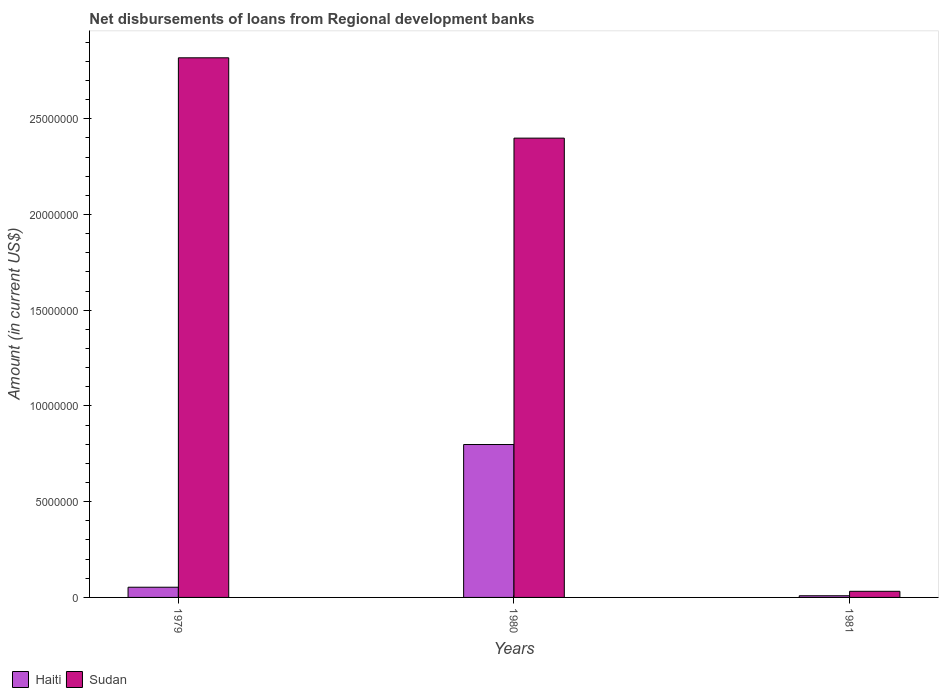How many different coloured bars are there?
Offer a very short reply. 2. How many groups of bars are there?
Make the answer very short. 3. Are the number of bars per tick equal to the number of legend labels?
Your answer should be very brief. Yes. Are the number of bars on each tick of the X-axis equal?
Your answer should be compact. Yes. How many bars are there on the 2nd tick from the left?
Offer a terse response. 2. How many bars are there on the 2nd tick from the right?
Your answer should be compact. 2. In how many cases, is the number of bars for a given year not equal to the number of legend labels?
Ensure brevity in your answer.  0. What is the amount of disbursements of loans from regional development banks in Sudan in 1980?
Provide a short and direct response. 2.40e+07. Across all years, what is the maximum amount of disbursements of loans from regional development banks in Sudan?
Keep it short and to the point. 2.82e+07. Across all years, what is the minimum amount of disbursements of loans from regional development banks in Sudan?
Provide a succinct answer. 3.20e+05. In which year was the amount of disbursements of loans from regional development banks in Sudan maximum?
Your answer should be very brief. 1979. In which year was the amount of disbursements of loans from regional development banks in Sudan minimum?
Your answer should be very brief. 1981. What is the total amount of disbursements of loans from regional development banks in Haiti in the graph?
Offer a very short reply. 8.61e+06. What is the difference between the amount of disbursements of loans from regional development banks in Haiti in 1980 and that in 1981?
Make the answer very short. 7.90e+06. What is the difference between the amount of disbursements of loans from regional development banks in Sudan in 1981 and the amount of disbursements of loans from regional development banks in Haiti in 1980?
Keep it short and to the point. -7.67e+06. What is the average amount of disbursements of loans from regional development banks in Sudan per year?
Your answer should be very brief. 1.75e+07. In the year 1979, what is the difference between the amount of disbursements of loans from regional development banks in Haiti and amount of disbursements of loans from regional development banks in Sudan?
Provide a short and direct response. -2.77e+07. What is the ratio of the amount of disbursements of loans from regional development banks in Haiti in 1980 to that in 1981?
Provide a short and direct response. 91.8. What is the difference between the highest and the second highest amount of disbursements of loans from regional development banks in Sudan?
Provide a succinct answer. 4.20e+06. What is the difference between the highest and the lowest amount of disbursements of loans from regional development banks in Sudan?
Make the answer very short. 2.79e+07. Is the sum of the amount of disbursements of loans from regional development banks in Haiti in 1979 and 1981 greater than the maximum amount of disbursements of loans from regional development banks in Sudan across all years?
Provide a succinct answer. No. What does the 2nd bar from the left in 1980 represents?
Keep it short and to the point. Sudan. What does the 1st bar from the right in 1981 represents?
Provide a succinct answer. Sudan. How many bars are there?
Keep it short and to the point. 6. Are all the bars in the graph horizontal?
Your answer should be very brief. No. How many years are there in the graph?
Offer a terse response. 3. What is the title of the graph?
Keep it short and to the point. Net disbursements of loans from Regional development banks. What is the label or title of the X-axis?
Provide a succinct answer. Years. What is the label or title of the Y-axis?
Provide a short and direct response. Amount (in current US$). What is the Amount (in current US$) in Haiti in 1979?
Ensure brevity in your answer.  5.33e+05. What is the Amount (in current US$) in Sudan in 1979?
Provide a succinct answer. 2.82e+07. What is the Amount (in current US$) of Haiti in 1980?
Provide a short and direct response. 7.99e+06. What is the Amount (in current US$) in Sudan in 1980?
Give a very brief answer. 2.40e+07. What is the Amount (in current US$) in Haiti in 1981?
Your response must be concise. 8.70e+04. What is the Amount (in current US$) in Sudan in 1981?
Provide a short and direct response. 3.20e+05. Across all years, what is the maximum Amount (in current US$) in Haiti?
Your answer should be very brief. 7.99e+06. Across all years, what is the maximum Amount (in current US$) of Sudan?
Your response must be concise. 2.82e+07. Across all years, what is the minimum Amount (in current US$) in Haiti?
Provide a succinct answer. 8.70e+04. Across all years, what is the minimum Amount (in current US$) in Sudan?
Keep it short and to the point. 3.20e+05. What is the total Amount (in current US$) in Haiti in the graph?
Your response must be concise. 8.61e+06. What is the total Amount (in current US$) in Sudan in the graph?
Your answer should be very brief. 5.25e+07. What is the difference between the Amount (in current US$) in Haiti in 1979 and that in 1980?
Your response must be concise. -7.45e+06. What is the difference between the Amount (in current US$) in Sudan in 1979 and that in 1980?
Ensure brevity in your answer.  4.20e+06. What is the difference between the Amount (in current US$) in Haiti in 1979 and that in 1981?
Your response must be concise. 4.46e+05. What is the difference between the Amount (in current US$) in Sudan in 1979 and that in 1981?
Give a very brief answer. 2.79e+07. What is the difference between the Amount (in current US$) of Haiti in 1980 and that in 1981?
Provide a succinct answer. 7.90e+06. What is the difference between the Amount (in current US$) in Sudan in 1980 and that in 1981?
Offer a terse response. 2.37e+07. What is the difference between the Amount (in current US$) of Haiti in 1979 and the Amount (in current US$) of Sudan in 1980?
Your answer should be compact. -2.35e+07. What is the difference between the Amount (in current US$) of Haiti in 1979 and the Amount (in current US$) of Sudan in 1981?
Provide a short and direct response. 2.13e+05. What is the difference between the Amount (in current US$) of Haiti in 1980 and the Amount (in current US$) of Sudan in 1981?
Make the answer very short. 7.67e+06. What is the average Amount (in current US$) in Haiti per year?
Give a very brief answer. 2.87e+06. What is the average Amount (in current US$) in Sudan per year?
Provide a short and direct response. 1.75e+07. In the year 1979, what is the difference between the Amount (in current US$) in Haiti and Amount (in current US$) in Sudan?
Give a very brief answer. -2.77e+07. In the year 1980, what is the difference between the Amount (in current US$) in Haiti and Amount (in current US$) in Sudan?
Offer a very short reply. -1.60e+07. In the year 1981, what is the difference between the Amount (in current US$) of Haiti and Amount (in current US$) of Sudan?
Your answer should be very brief. -2.33e+05. What is the ratio of the Amount (in current US$) of Haiti in 1979 to that in 1980?
Make the answer very short. 0.07. What is the ratio of the Amount (in current US$) of Sudan in 1979 to that in 1980?
Your answer should be compact. 1.17. What is the ratio of the Amount (in current US$) of Haiti in 1979 to that in 1981?
Your answer should be compact. 6.13. What is the ratio of the Amount (in current US$) of Sudan in 1979 to that in 1981?
Provide a short and direct response. 88.08. What is the ratio of the Amount (in current US$) in Haiti in 1980 to that in 1981?
Provide a short and direct response. 91.8. What is the ratio of the Amount (in current US$) of Sudan in 1980 to that in 1981?
Your answer should be very brief. 74.97. What is the difference between the highest and the second highest Amount (in current US$) of Haiti?
Offer a very short reply. 7.45e+06. What is the difference between the highest and the second highest Amount (in current US$) of Sudan?
Offer a terse response. 4.20e+06. What is the difference between the highest and the lowest Amount (in current US$) in Haiti?
Ensure brevity in your answer.  7.90e+06. What is the difference between the highest and the lowest Amount (in current US$) of Sudan?
Provide a short and direct response. 2.79e+07. 